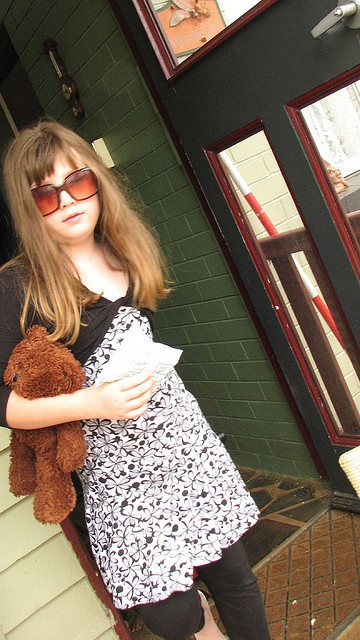Describe the objects in this image and their specific colors. I can see people in black, white, gray, and maroon tones and teddy bear in black, brown, maroon, and red tones in this image. 